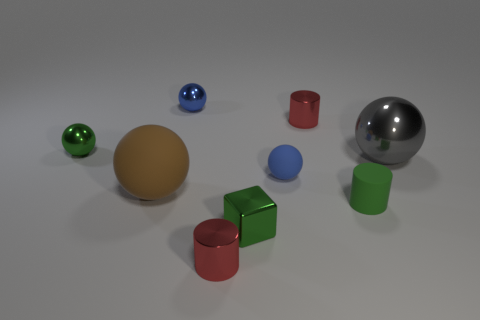Are there any green balls behind the large gray thing?
Your answer should be compact. Yes. What number of objects are there?
Provide a short and direct response. 9. What number of small red objects are in front of the gray ball that is on the right side of the blue metal sphere?
Offer a very short reply. 1. Do the matte cylinder and the matte sphere right of the blue shiny object have the same color?
Offer a terse response. No. How many small blue rubber things have the same shape as the large metal object?
Keep it short and to the point. 1. There is a blue sphere in front of the gray object; what is it made of?
Make the answer very short. Rubber. Does the tiny blue thing that is right of the small blue metal ball have the same shape as the green rubber thing?
Give a very brief answer. No. Are there any purple metallic blocks of the same size as the brown rubber ball?
Your answer should be compact. No. Do the tiny green matte object and the small metallic object that is to the right of the small blue matte sphere have the same shape?
Your response must be concise. Yes. What is the shape of the matte thing that is the same color as the metallic cube?
Offer a terse response. Cylinder. 